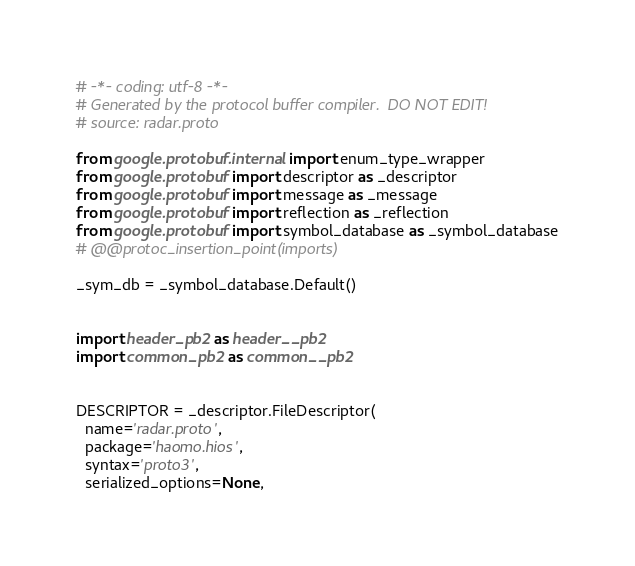Convert code to text. <code><loc_0><loc_0><loc_500><loc_500><_Python_># -*- coding: utf-8 -*-
# Generated by the protocol buffer compiler.  DO NOT EDIT!
# source: radar.proto

from google.protobuf.internal import enum_type_wrapper
from google.protobuf import descriptor as _descriptor
from google.protobuf import message as _message
from google.protobuf import reflection as _reflection
from google.protobuf import symbol_database as _symbol_database
# @@protoc_insertion_point(imports)

_sym_db = _symbol_database.Default()


import header_pb2 as header__pb2
import common_pb2 as common__pb2


DESCRIPTOR = _descriptor.FileDescriptor(
  name='radar.proto',
  package='haomo.hios',
  syntax='proto3',
  serialized_options=None,</code> 